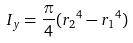Convert formula to latex. <formula><loc_0><loc_0><loc_500><loc_500>I _ { y } = \frac { \pi } { 4 } ( { r _ { 2 } } ^ { 4 } - { r _ { 1 } } ^ { 4 } )</formula> 